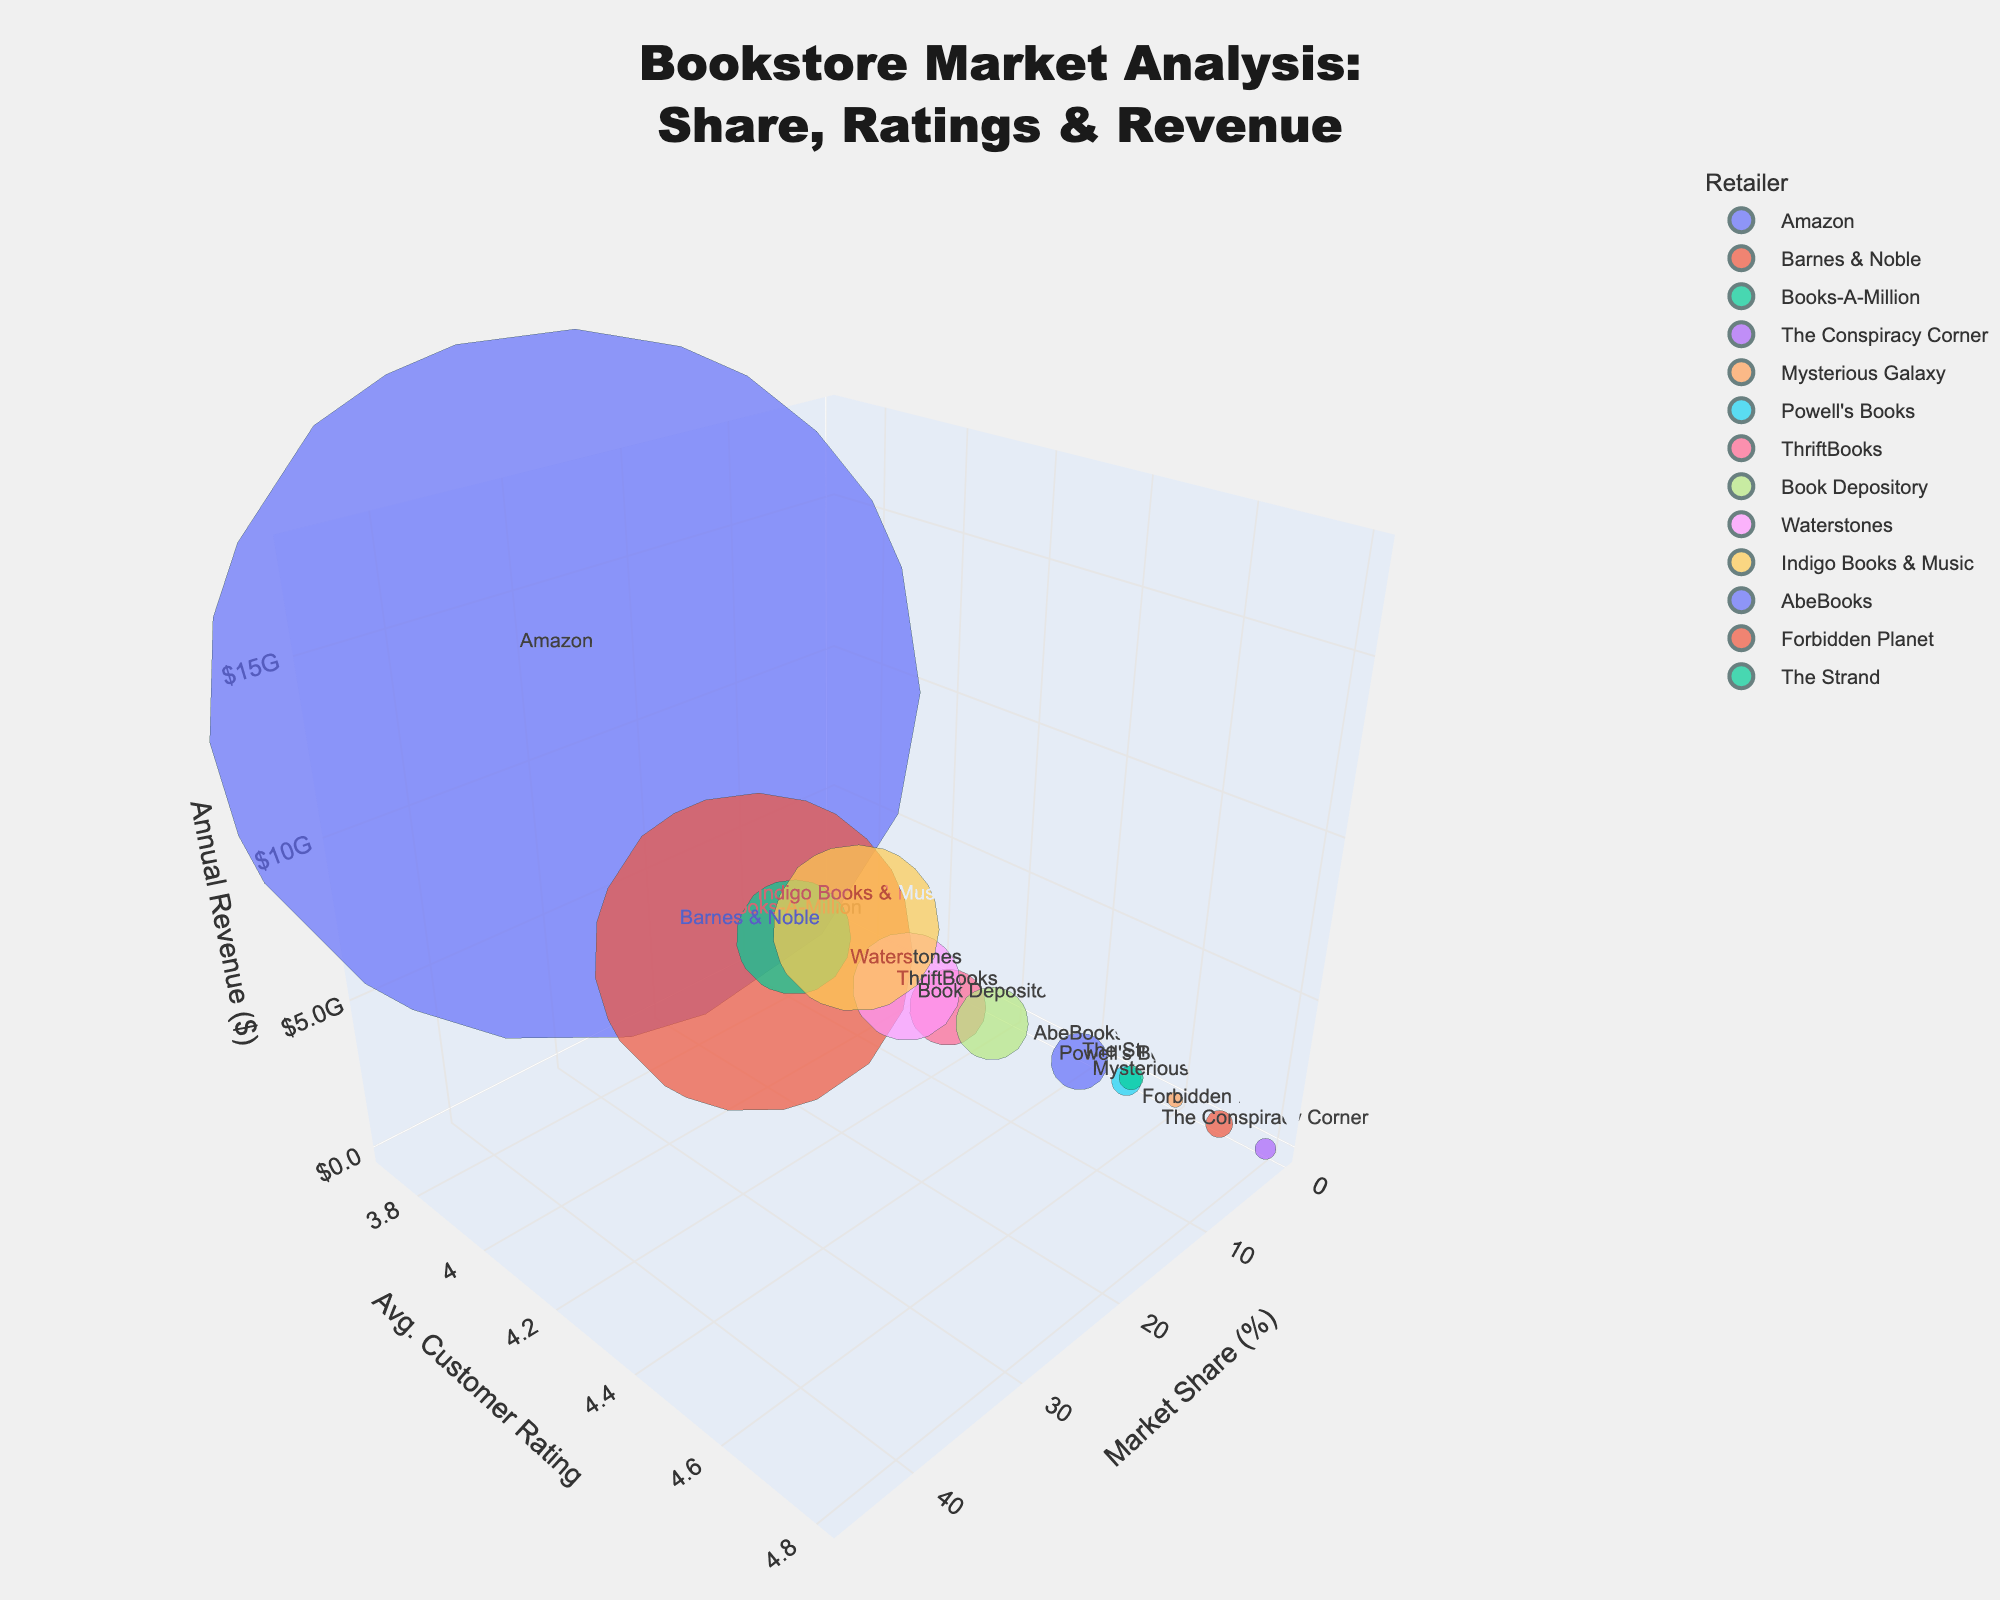What is the title of the figure? The title is provided at the top of the figure.
Answer: "Bookstore Market Analysis: Share, Ratings & Revenue" How many retailers are represented in the chart? Count the number of unique retailer names.
Answer: 13 What is the axis label for the x-axis? The x-axis is labeled as "Market Share (%)".
Answer: Market Share (%) What color represents Amazon in the chart? The chart uses different colors for each retailer; Amazon is assigned its specific color.
Answer: (Color visible from the chart) Which retailer has the highest market share and what is its value? Observing the x-axis, we can see which retailer's bubble is farthest along the axis, and the hover text will show the exact value.
Answer: Amazon, 45.2% What's the total market share of independent bookstores? Sum the market shares of The Conspiracy Corner, Mysterious Galaxy, Powell's Books, and The Strand.
Answer: 3.1% What's the average customer rating for retailers with a market share below 1%? Sum the ratings of The Conspiracy Corner (4.8), Mysterious Galaxy (4.6), Forbidden Planet (4.7), and The Strand (4.5), then divide by 4.
Answer: 4.65 Which retailer has the lowest market share and what is its annual revenue? The smallest bubble along the x-axis represents the retailer with the lowest market share. Confirm with hover text.
Answer: Mysterious Galaxy, $8,000,000 Which retailer has a higher average customer rating, Powell's Books or Waterstones? Compare the y-axis positions of Powell's Books and Waterstones, checking their hover-text values.
Answer: Powell's Books Which has a larger annual revenue, Barnes & Noble or ThriftBooks? Compare the z-axis positions of Barnes & Noble and ThriftBooks, checking their hover-text values.
Answer: Barnes & Noble Which retailers have an average customer rating of 4.5 or higher, and what are their market shares? Check the y-axis values for 4.5 or higher and identify corresponding retailers and their market shares from hover-text.
Answer: The Conspiracy Corner (0.8%), Mysterious Galaxy (0.5%), Powell's Books (1.2%), AbeBooks (1.9%), Forbidden Planet (0.7%) Which retailer has the largest bubble and why? The bubble size correlates with annual revenue, and the larger the bubble, the higher the revenue; observe and refer to hover-text.
Answer: Amazon, due to the highest annual revenue How does the market share of Powell's Books compare to AbeBooks? Compare the positions of their bubbles along the x-axis; Powell's Books' share is slightly greater.
Answer: Powell's Books' market share (1.2%) is slightly higher than AbeBooks (1.9%) Which retailer's bubble is located highest along the z-axis, and what does it indicate? The highest bubble on the z-axis indicates the maximum annual revenue. The retailer can be identified via hover-text.
Answer: Amazon, indicating the highest annual revenue 